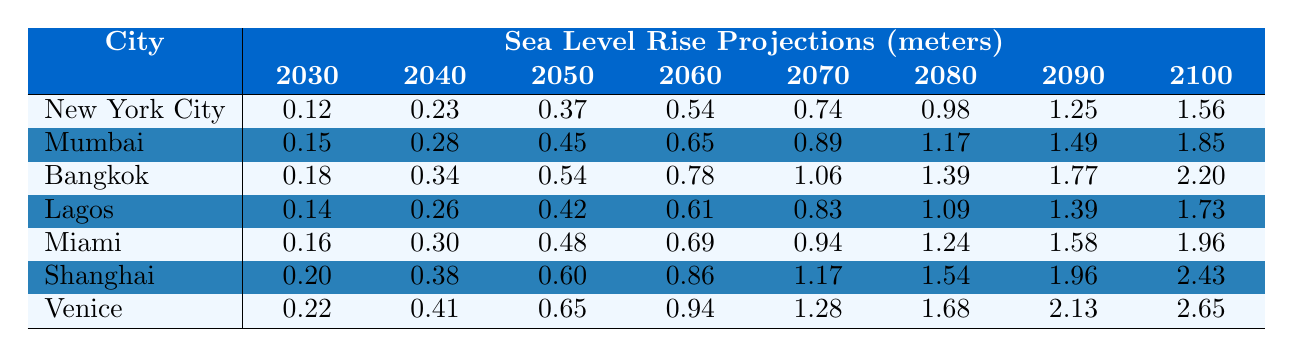What is the projected sea level rise for New York City in 2040? According to the table, the sea level rise for New York City in 2040 is given as 0.23 meters.
Answer: 0.23 meters Which city is projected to have the highest sea level rise by 2100? The table shows that Venice has the highest projected sea level rise at 2.65 meters by 2100.
Answer: Venice What is the increase in sea level rise for Mumbai from 2030 to 2060? For Mumbai, the sea level rise in 2030 is 0.15 meters and in 2060 is 0.65 meters. The increase is calculated as 0.65 - 0.15 = 0.50 meters.
Answer: 0.50 meters What is the average sea level rise for Bangkok between 2040 and 2080? The values for Bangkok in the specified years are 0.34 meters (2040), 0.54 meters (2050), 0.78 meters (2060), 1.06 meters (2070), and 1.39 meters (2080). Summing these: 0.34 + 0.54 + 0.78 + 1.06 + 1.39 = 4.11. There are 5 entries, so the average is 4.11 / 5 = 0.822 meters.
Answer: 0.822 meters Is it true that the sea level rise for Miami in 2070 is less than that for Shanghai in the same year? The table shows that the sea level rise for Miami in 2070 is 0.94 meters, while for Shanghai it is 1.17 meters. Since 0.94 is less than 1.17, the statement is true.
Answer: True What is the total sea level rise for Lagos from 2030 to 2090? The sea level rise values for Lagos over the years are 0.14 meters (2030), 0.26 meters (2040), 0.42 meters (2050), 0.61 meters (2060), 0.83 meters (2070), 1.09 meters (2080), and 1.39 meters (2090). Summing these values: 0.14 + 0.26 + 0.42 + 0.61 + 0.83 + 1.09 + 1.39 = 4.74 meters.
Answer: 4.74 meters Which city has the lowest projected increase in sea level rise from 2030 to 2100? By comparing the increases from 2030 to 2100 for all cities, Lagos has an increase from 0.14 to 1.73 meters, which is 1.59 meters, whereas New York City increases from 0.12 to 1.56 meters (1.44 meters). The smallest increase is for New York City.
Answer: New York City What is the cumulative sea level rise for Shanghai from 2030 to 2080? The sea levels for Shanghai are 0.20 meters (2030), 0.38 meters (2040), 0.60 meters (2050), 0.86 meters (2060), 1.17 meters (2070), and 1.54 meters (2080). Adding these values gives: 0.20 + 0.38 + 0.60 + 0.86 + 1.17 + 1.54 = 4.75 meters.
Answer: 4.75 meters In which decade is the rise in sea level for Venice the greatest when compared to the previous decade? The table lists the sea level rise for Venice by decade. The greatest increase occurs between 2090 and 2100, where the rise goes from 2.13 meters to 2.65 meters, an increase of 0.52 meters, which is greater than any other decade.
Answer: 2090 to 2100 